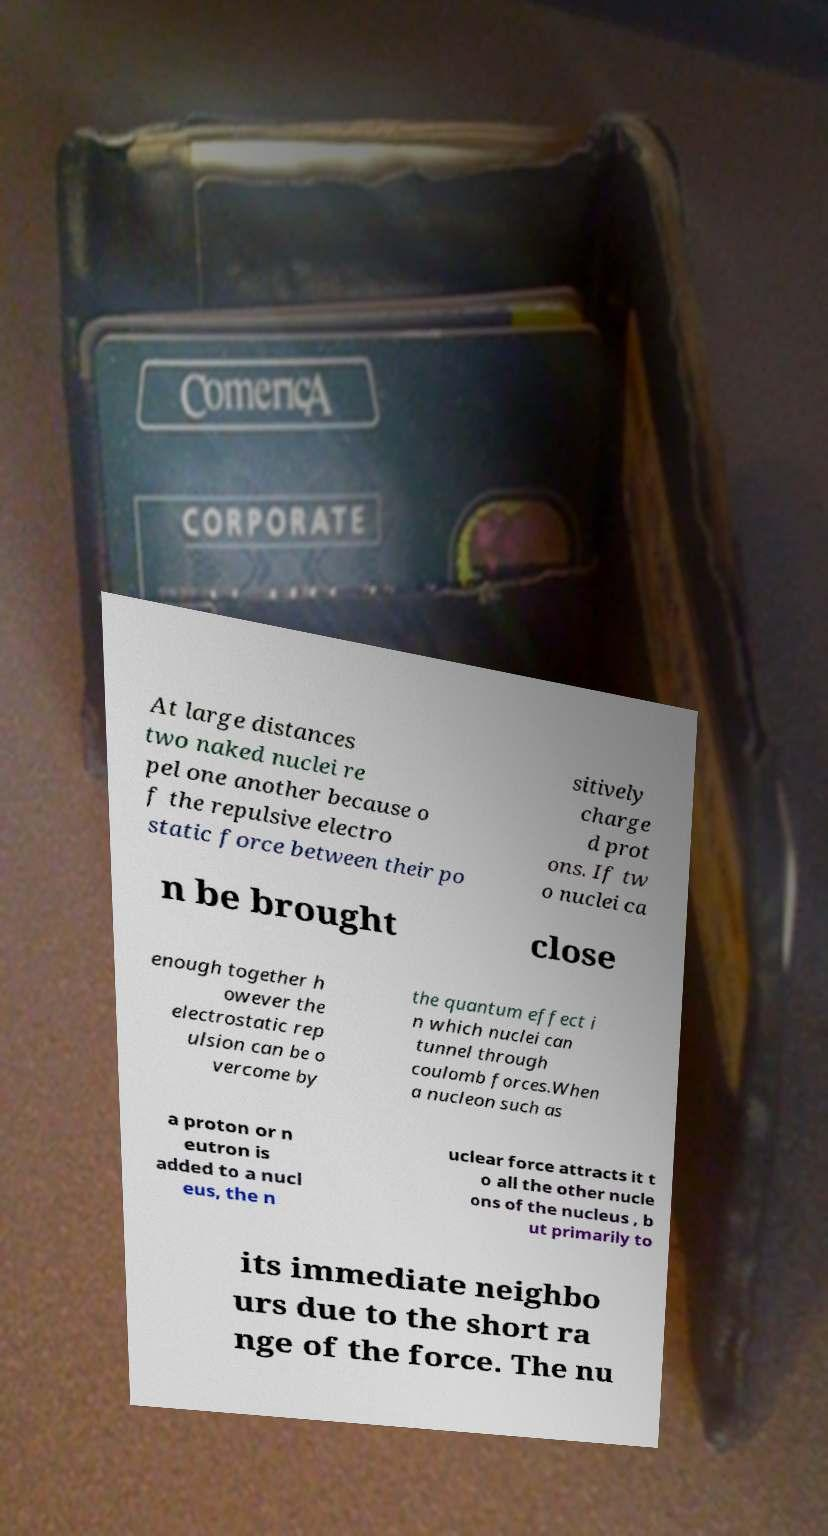Can you read and provide the text displayed in the image?This photo seems to have some interesting text. Can you extract and type it out for me? At large distances two naked nuclei re pel one another because o f the repulsive electro static force between their po sitively charge d prot ons. If tw o nuclei ca n be brought close enough together h owever the electrostatic rep ulsion can be o vercome by the quantum effect i n which nuclei can tunnel through coulomb forces.When a nucleon such as a proton or n eutron is added to a nucl eus, the n uclear force attracts it t o all the other nucle ons of the nucleus , b ut primarily to its immediate neighbo urs due to the short ra nge of the force. The nu 